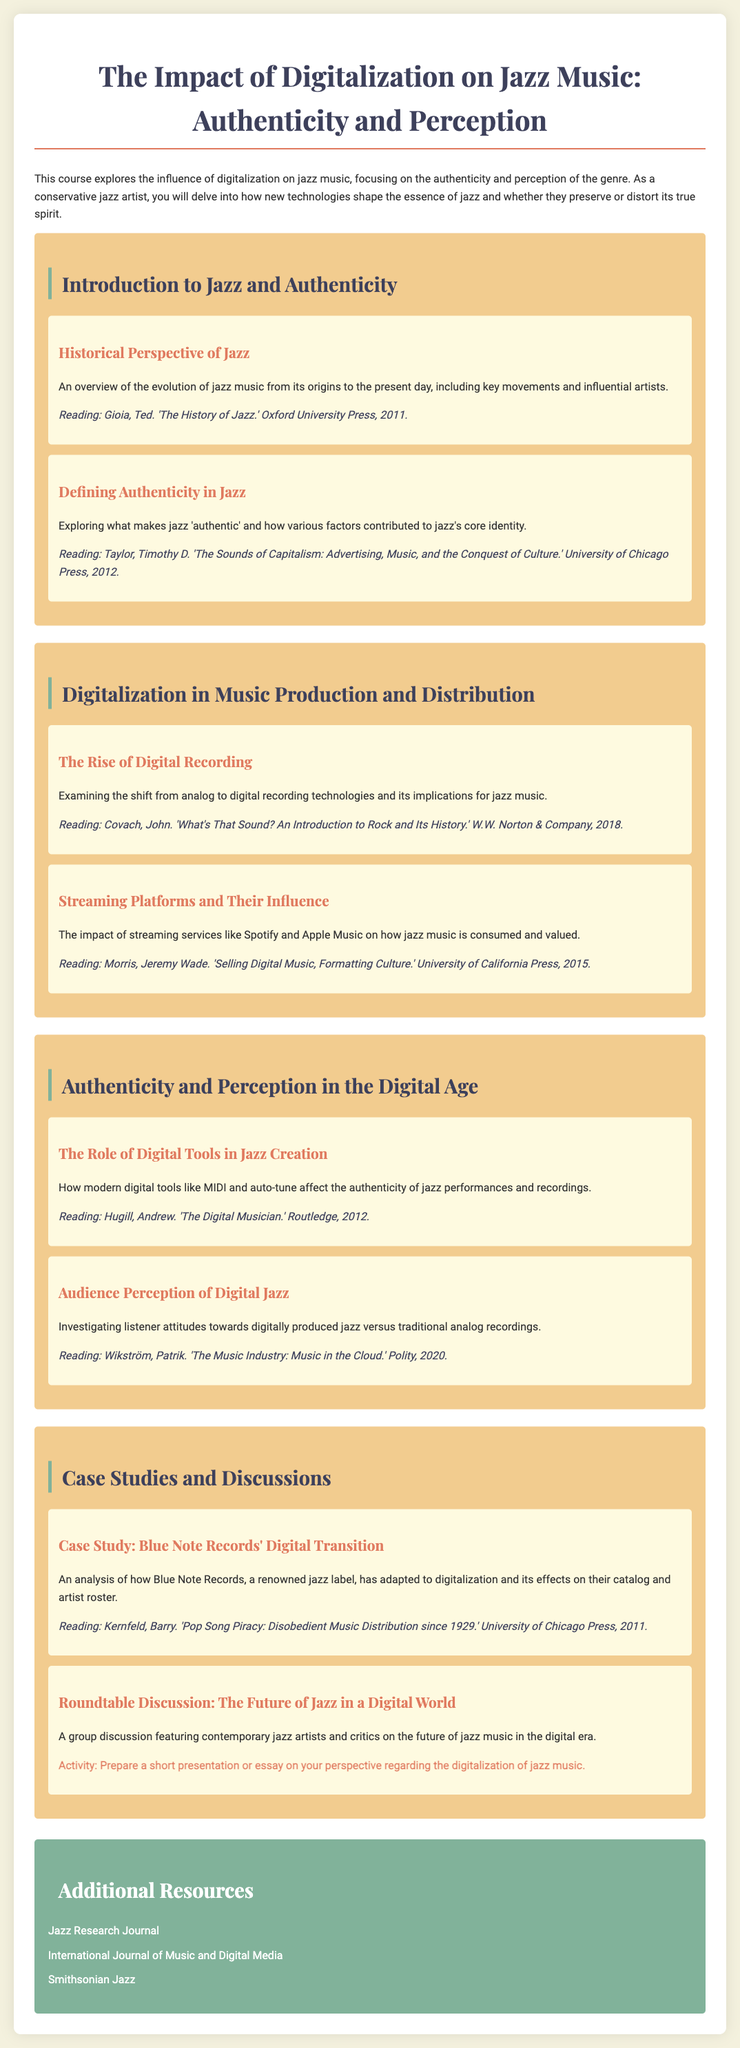What is the title of the course? The title of the course is presented at the top of the document.
Answer: The Impact of Digitalization on Jazz Music: Authenticity and Perception Who is the author of 'The History of Jazz'? The document mentions an author known for this work in the reading section.
Answer: Ted Gioia What are the two main issues addressed in the course? The introductory text outlines the core themes of the course concerning jazz music.
Answer: Authenticity and perception What is the reading for 'Defining Authenticity in Jazz'? The reading associated with this section is specified in the document.
Answer: Taylor, Timothy D. 'The Sounds of Capitalism: Advertising, Music, and the Conquest of Culture.' University of Chicago Press, 2012 Which digital tool is mentioned in the context of jazz creation? The content discusses modern digital tools affecting jazz performances.
Answer: MIDI What is the main subject of the roundtable discussion? The document outlines the focus of the discussion at the end of the course modules.
Answer: The future of jazz in a digital world Who published 'Selling Digital Music, Formatting Culture'? The document specifies the publisher of this reading material.
Answer: University of California Press How many modules are in the course syllabus? By reviewing the structure of the syllabus, one can identify the number of distinct modules.
Answer: Four 